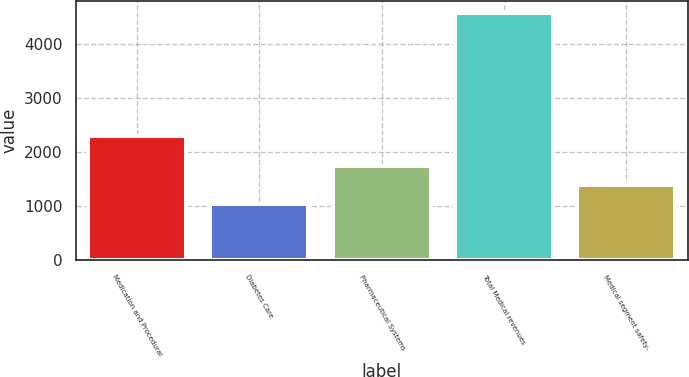<chart> <loc_0><loc_0><loc_500><loc_500><bar_chart><fcel>Medication and Procedural<fcel>Diabetes Care<fcel>Pharmaceutical Systems<fcel>Total Medical revenues<fcel>Medical segment safety-<nl><fcel>2307<fcel>1037<fcel>1744.2<fcel>4573<fcel>1390.6<nl></chart> 